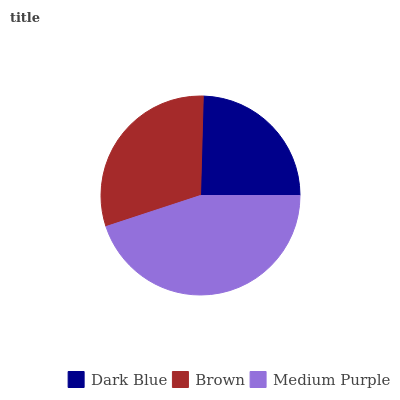Is Dark Blue the minimum?
Answer yes or no. Yes. Is Medium Purple the maximum?
Answer yes or no. Yes. Is Brown the minimum?
Answer yes or no. No. Is Brown the maximum?
Answer yes or no. No. Is Brown greater than Dark Blue?
Answer yes or no. Yes. Is Dark Blue less than Brown?
Answer yes or no. Yes. Is Dark Blue greater than Brown?
Answer yes or no. No. Is Brown less than Dark Blue?
Answer yes or no. No. Is Brown the high median?
Answer yes or no. Yes. Is Brown the low median?
Answer yes or no. Yes. Is Dark Blue the high median?
Answer yes or no. No. Is Dark Blue the low median?
Answer yes or no. No. 